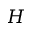<formula> <loc_0><loc_0><loc_500><loc_500>H</formula> 